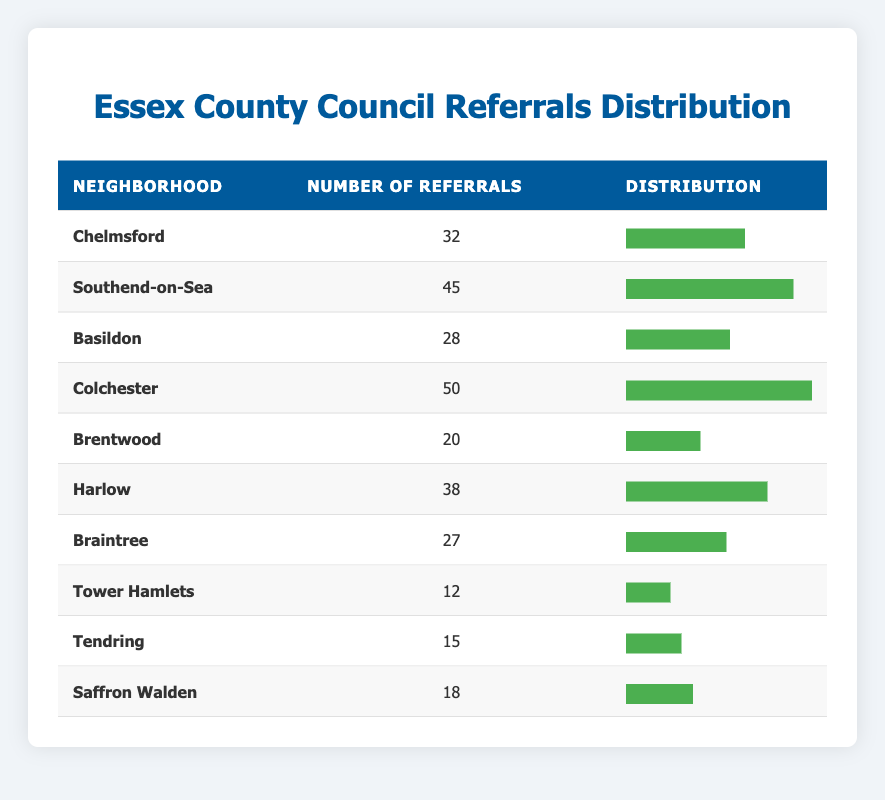What is the neighborhood with the highest number of referrals? In the table, we compare the number of referrals across all neighborhoods. Colchester has the highest number of referrals at 50.
Answer: Colchester How many referrals did Brentwood receive? The table lists Brentwood with 20 referrals.
Answer: 20 What is the total number of referrals received by all neighborhoods combined? We can sum the referrals from each neighborhood: 32 + 45 + 28 + 50 + 20 + 38 + 27 + 12 + 15 + 18 =  315
Answer: 315 Is the number of referrals from Harlow greater than the number from Braintree? Harlow has 38 referrals and Braintree has 27 referrals. Since 38 is greater than 27, the statement is true.
Answer: Yes What is the average number of referrals per neighborhood? There are 10 neighborhoods total. We total the number of referrals (315) and divide by 10, which gives us an average of 31.5 referrals per neighborhood.
Answer: 31.5 Which neighborhood has the fewest referrals? By scanning the table, Tower Hamlets has the least referrals at 12.
Answer: Tower Hamlets How many neighborhoods have more than 30 referrals? Referring to the table, the neighborhoods with more than 30 referrals are Chelmsford, Southend-on-Sea, Colchester, and Harlow, totaling 4 neighborhoods.
Answer: 4 What is the difference in the number of referrals between Southend-on-Sea and Tendring? Southend-on-Sea has 45 referrals and Tendring has 15 referrals. The difference is calculated by subtracting: 45 - 15 = 30.
Answer: 30 Does Saffron Walden have more referrals than Basildon? Saffron Walden has 18 referrals while Basildon has 28 referrals. Therefore, Saffron Walden does not have more referrals than Basildon, making this statement false.
Answer: No 